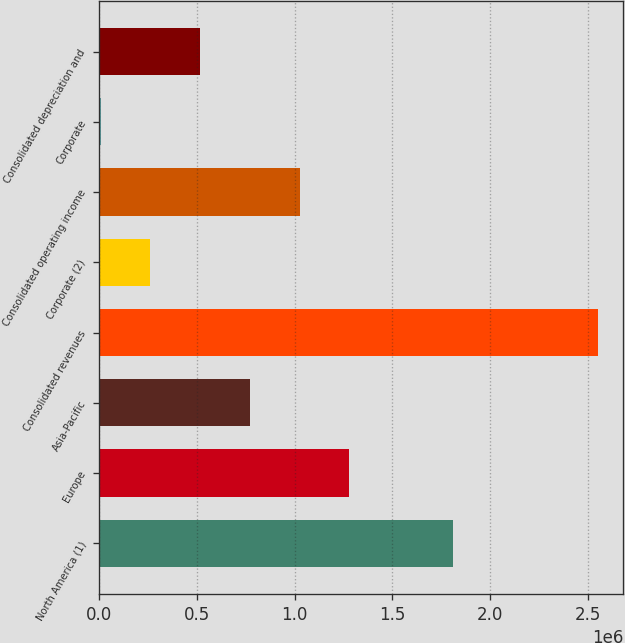Convert chart. <chart><loc_0><loc_0><loc_500><loc_500><bar_chart><fcel>North America (1)<fcel>Europe<fcel>Asia-Pacific<fcel>Consolidated revenues<fcel>Corporate (2)<fcel>Consolidated operating income<fcel>Corporate<fcel>Consolidated depreciation and<nl><fcel>1.80899e+06<fcel>1.2803e+06<fcel>770730<fcel>2.55424e+06<fcel>261158<fcel>1.02552e+06<fcel>6371<fcel>515944<nl></chart> 